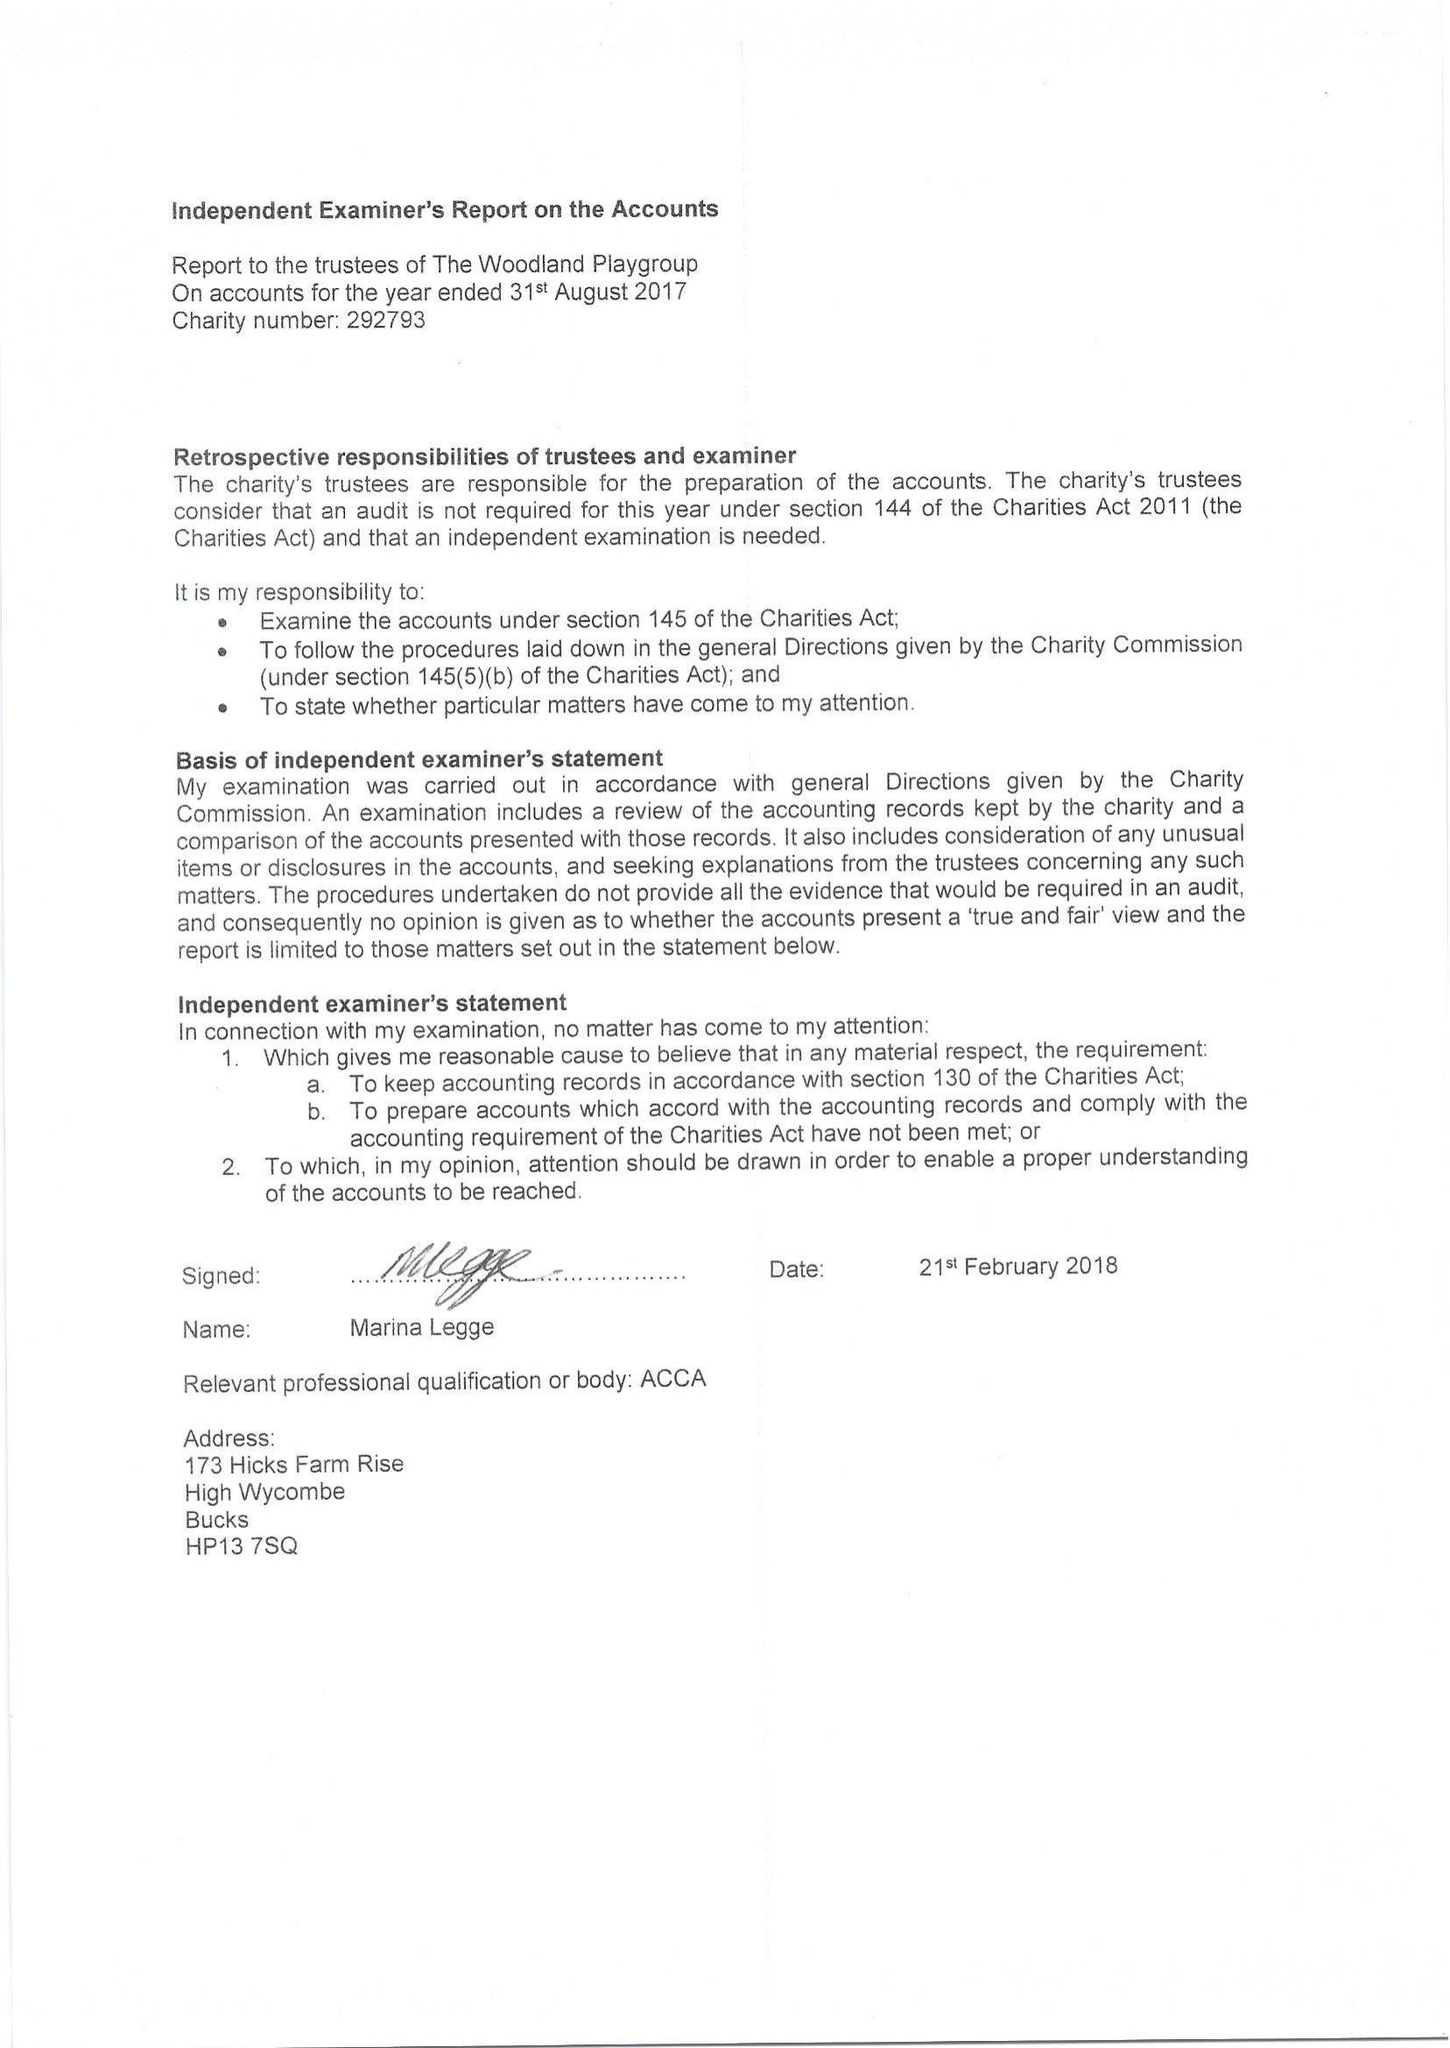What is the value for the address__street_line?
Answer the question using a single word or phrase. COATES LANE 